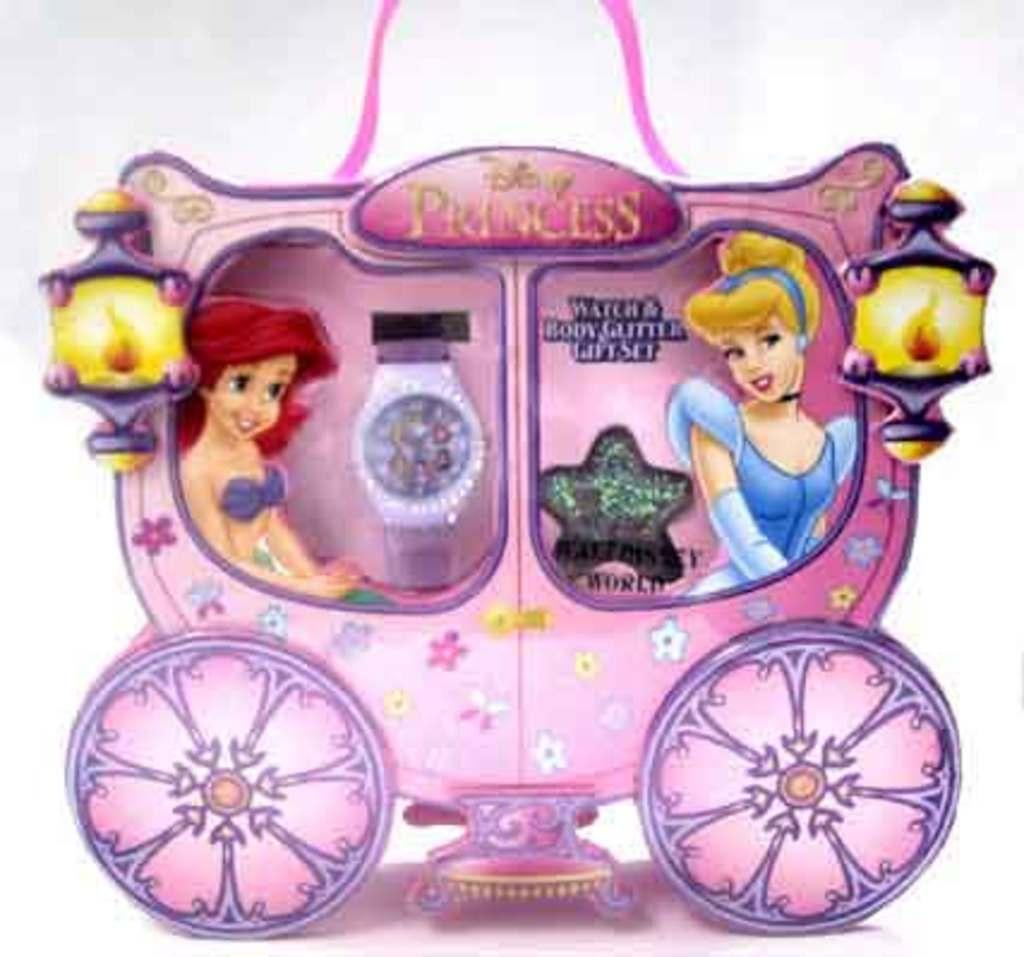<image>
Relay a brief, clear account of the picture shown. a box that says 'disney princess' at the top of it 